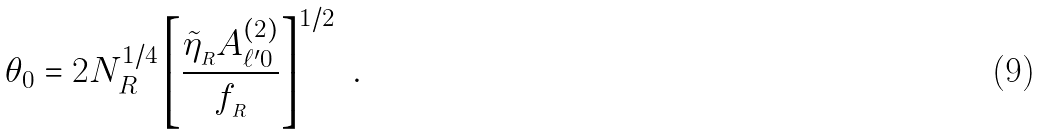Convert formula to latex. <formula><loc_0><loc_0><loc_500><loc_500>\theta _ { 0 } = 2 N _ { R } ^ { 1 / 4 } \left [ \frac { \tilde { \eta } _ { _ { R } } A _ { \ell ^ { \prime } 0 } ^ { ( 2 ) } } { f _ { _ { R } } } \right ] ^ { 1 / 2 } \ .</formula> 